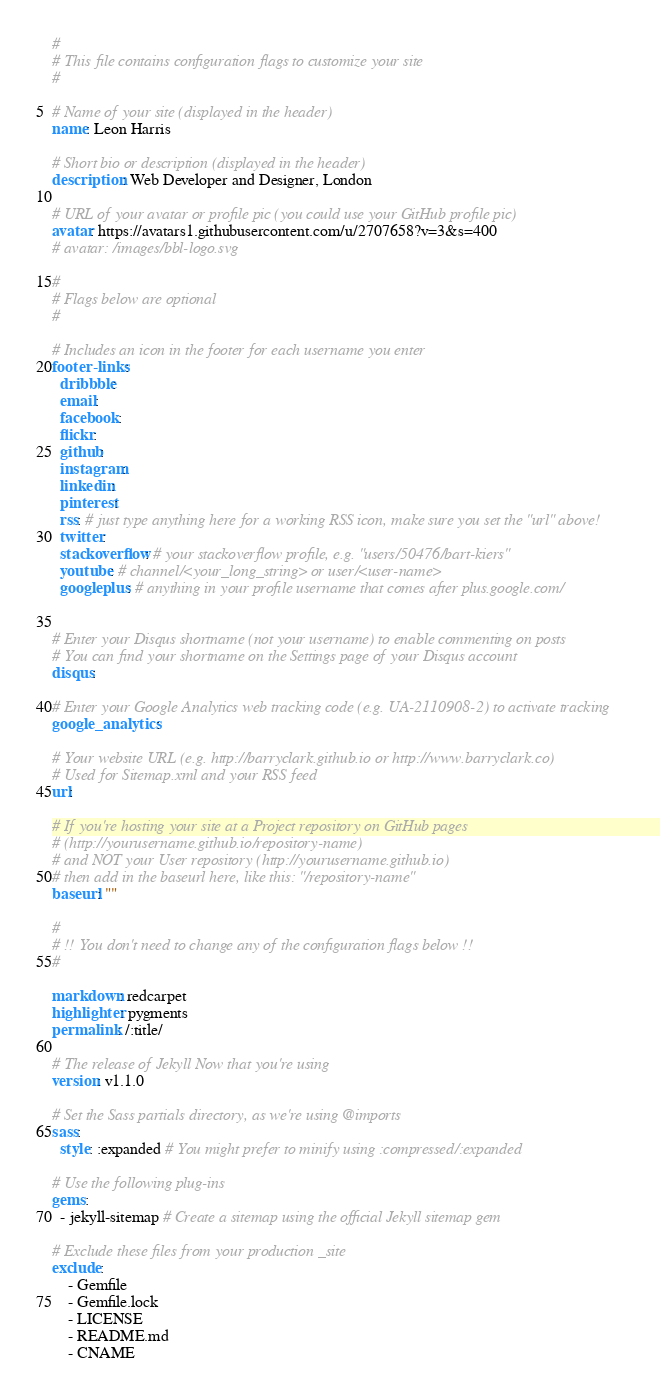<code> <loc_0><loc_0><loc_500><loc_500><_YAML_>#
# This file contains configuration flags to customize your site
#

# Name of your site (displayed in the header)
name: Leon Harris

# Short bio or description (displayed in the header)
description: Web Developer and Designer, London

# URL of your avatar or profile pic (you could use your GitHub profile pic)
avatar: https://avatars1.githubusercontent.com/u/2707658?v=3&s=400
# avatar: /images/bbl-logo.svg

#
# Flags below are optional
#

# Includes an icon in the footer for each username you enter
footer-links:
  dribbble:
  email:
  facebook:
  flickr: 
  github:
  instagram: 
  linkedin:
  pinterest:
  rss: # just type anything here for a working RSS icon, make sure you set the "url" above!
  twitter: 
  stackoverflow: # your stackoverflow profile, e.g. "users/50476/bart-kiers"
  youtube: # channel/<your_long_string> or user/<user-name>
  googleplus: # anything in your profile username that comes after plus.google.com/


# Enter your Disqus shortname (not your username) to enable commenting on posts
# You can find your shortname on the Settings page of your Disqus account
disqus:

# Enter your Google Analytics web tracking code (e.g. UA-2110908-2) to activate tracking
google_analytics:

# Your website URL (e.g. http://barryclark.github.io or http://www.barryclark.co)
# Used for Sitemap.xml and your RSS feed
url:

# If you're hosting your site at a Project repository on GitHub pages
# (http://yourusername.github.io/repository-name)
# and NOT your User repository (http://yourusername.github.io)
# then add in the baseurl here, like this: "/repository-name"
baseurl: ""

#
# !! You don't need to change any of the configuration flags below !!
#

markdown: redcarpet
highlighter: pygments
permalink: /:title/

# The release of Jekyll Now that you're using
version: v1.1.0

# Set the Sass partials directory, as we're using @imports
sass:
  style: :expanded # You might prefer to minify using :compressed/:expanded

# Use the following plug-ins
gems:
  - jekyll-sitemap # Create a sitemap using the official Jekyll sitemap gem

# Exclude these files from your production _site
exclude:
    - Gemfile
    - Gemfile.lock
    - LICENSE
    - README.md
    - CNAME
</code> 